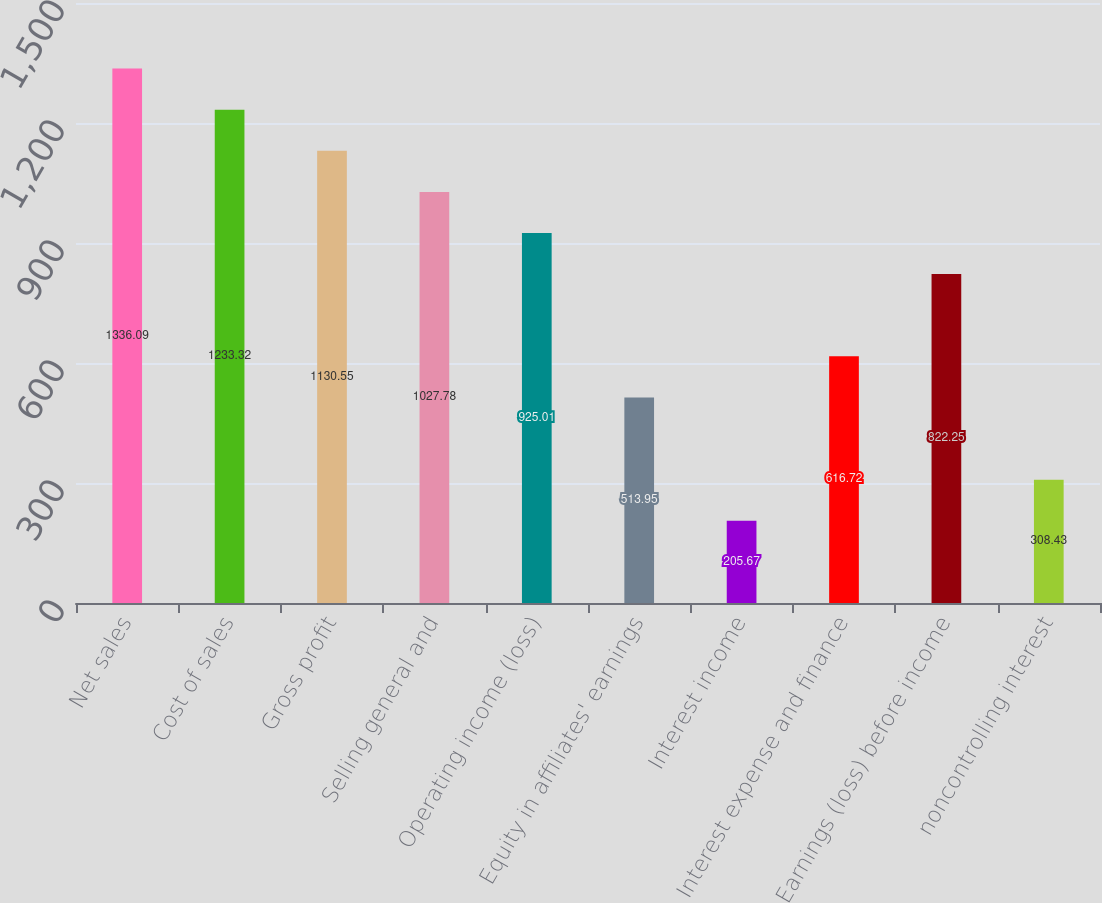Convert chart. <chart><loc_0><loc_0><loc_500><loc_500><bar_chart><fcel>Net sales<fcel>Cost of sales<fcel>Gross profit<fcel>Selling general and<fcel>Operating income (loss)<fcel>Equity in affiliates' earnings<fcel>Interest income<fcel>Interest expense and finance<fcel>Earnings (loss) before income<fcel>noncontrolling interest<nl><fcel>1336.09<fcel>1233.32<fcel>1130.55<fcel>1027.78<fcel>925.01<fcel>513.95<fcel>205.67<fcel>616.72<fcel>822.25<fcel>308.43<nl></chart> 